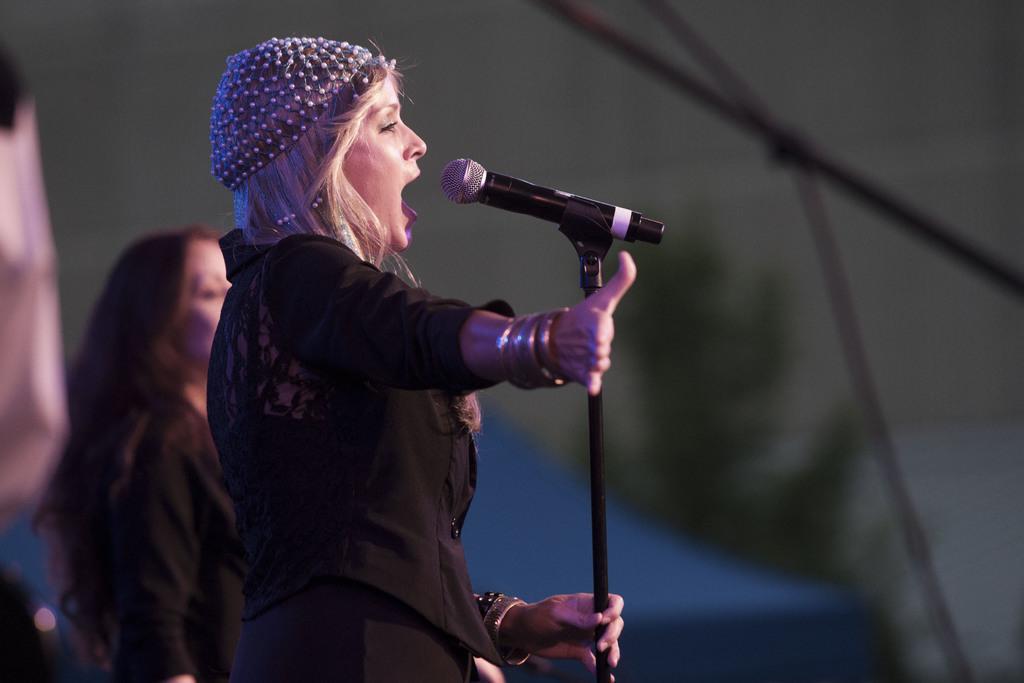How would you summarize this image in a sentence or two? In the image I can a person who is standing in front of the mic and to the side there is an other person. 